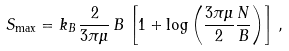<formula> <loc_0><loc_0><loc_500><loc_500>S _ { \max } = k _ { B } \, \frac { 2 } { 3 \pi \mu } \, B \, \left [ 1 + \log \left ( \frac { 3 \pi \mu } { 2 } \frac { N } { B } \right ) \right ] \, ,</formula> 